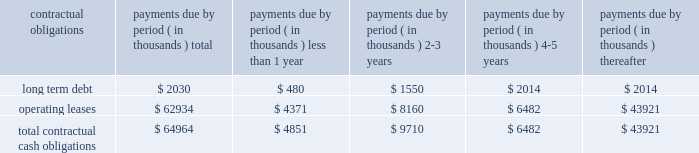Under this line are primarily used by our european subsidiaries to settle intercompany sales and are denominated in the respective local currencies of its european subsidiaries .
The line of credit may be canceled by the bank with 30 days notice .
At september 27 , 2003 , there were no outstanding borrowings under this line .
In september 2001 we obtained a secured loan from wells fargo foothill , inc .
The loan agreement with wells fargo foothill , inc .
Provides for a term loan of approximately $ 2.4 million , which we borrowed at signing , and a revolving line of credit facility .
The maximum amount we can borrow under the loan agreement and amendments is $ 20.0 million .
The loan agreement and amendments contain financial and other covenants and the actual amount which we can borrow under the line of credit at any time is based upon a formula tied to the amount of our qualifying accounts receivable .
In july 2003 we amended this loan agreement primarily to simplify financial covenants and to reduce the fees related to this facility .
The term loan accrues interest at prime plus 1.0% ( 1.0 % ) for five years .
The line of credit advances accrue interest at prime plus 0.25% ( 0.25 % ) .
The line of credit expires in september 2005 .
We were in compliance with all covenants as of september 27 , 2003 .
In april 2002 , we began an implementation project for an integrated enterprise wide software application .
We began operational use of this software application at the bedford , ma and newark , de facilities on november 24 , 2002 , at the danbury , ct facility on february 24 , 2003 and at the brussels , belgium location on october 2 , 2003 .
Through september 27 , 2003 we have made payments totaling $ 3.4 million for hardware , software and consulting services representing substantially all of our capital commitments related to this implementation project .
Most of the cost has been capitalized and we began to amortize these costs over their expected useful lives in december 2002 .
In september 2002 , we completed a sale/leaseback transaction for our headquarters and manufacturing facility located in bedford , massachusetts and our lorad manufacturing facility in danbury , connecticut .
The transaction resulted in net proceeds to us of $ 31.4 million .
The new lease for these facilities , including the associated land , has a term of 20 years , with four five-year year renewal terms , which we may exercise at our option .
The basic rent for the facilities is $ 3.2 million per year , which is subject to adjustment for increases in the consumer price index .
The aggregate total minimum lease payments during the initial 20-year term are $ 62.9 million .
In addition , we are required to maintain the facilities during the term of the lease and to pay all taxes , insurance , utilities and other costs associated with those facilities .
Under the lease , we make customary representations and warranties and agree to certain financial covenants and indemnities .
In the event we default on the lease , the landlord may terminate the lease , accelerate payments and collect liquidated damages .
The table summarizes our contractual obligations and commitments as of september 27 , 2003 : payments due by period ( in thousands ) contractual obligations total less than 1 year years thereafter .
Except as set forth above , we do not have any other significant capital commitments .
We are working on several projects , with an emphasis on direct radiography plates .
We believe that we have sufficient funds in order to fund our expected operations over the next twelve months .
Recent accounting pronouncements in december 2002 , sfas no .
148 , accounting for stock-based compensation 2013 transition and disclosure was issued .
Sfas no .
148 amends sfas no .
123 to provide alternative methods of transition to the fair value method of accounting for stock-based employee compensation .
In addition , sfas no .
148 amends the disclosure provisions of sfas no .
123 to require disclosure in the summary of significant accounting policies of the effects .
What percentage of total contractual obligations and commitments as of september 27 , 2003 : payments due is composed of long term debt? 
Computations: (2030 / 64964)
Answer: 0.03125. 